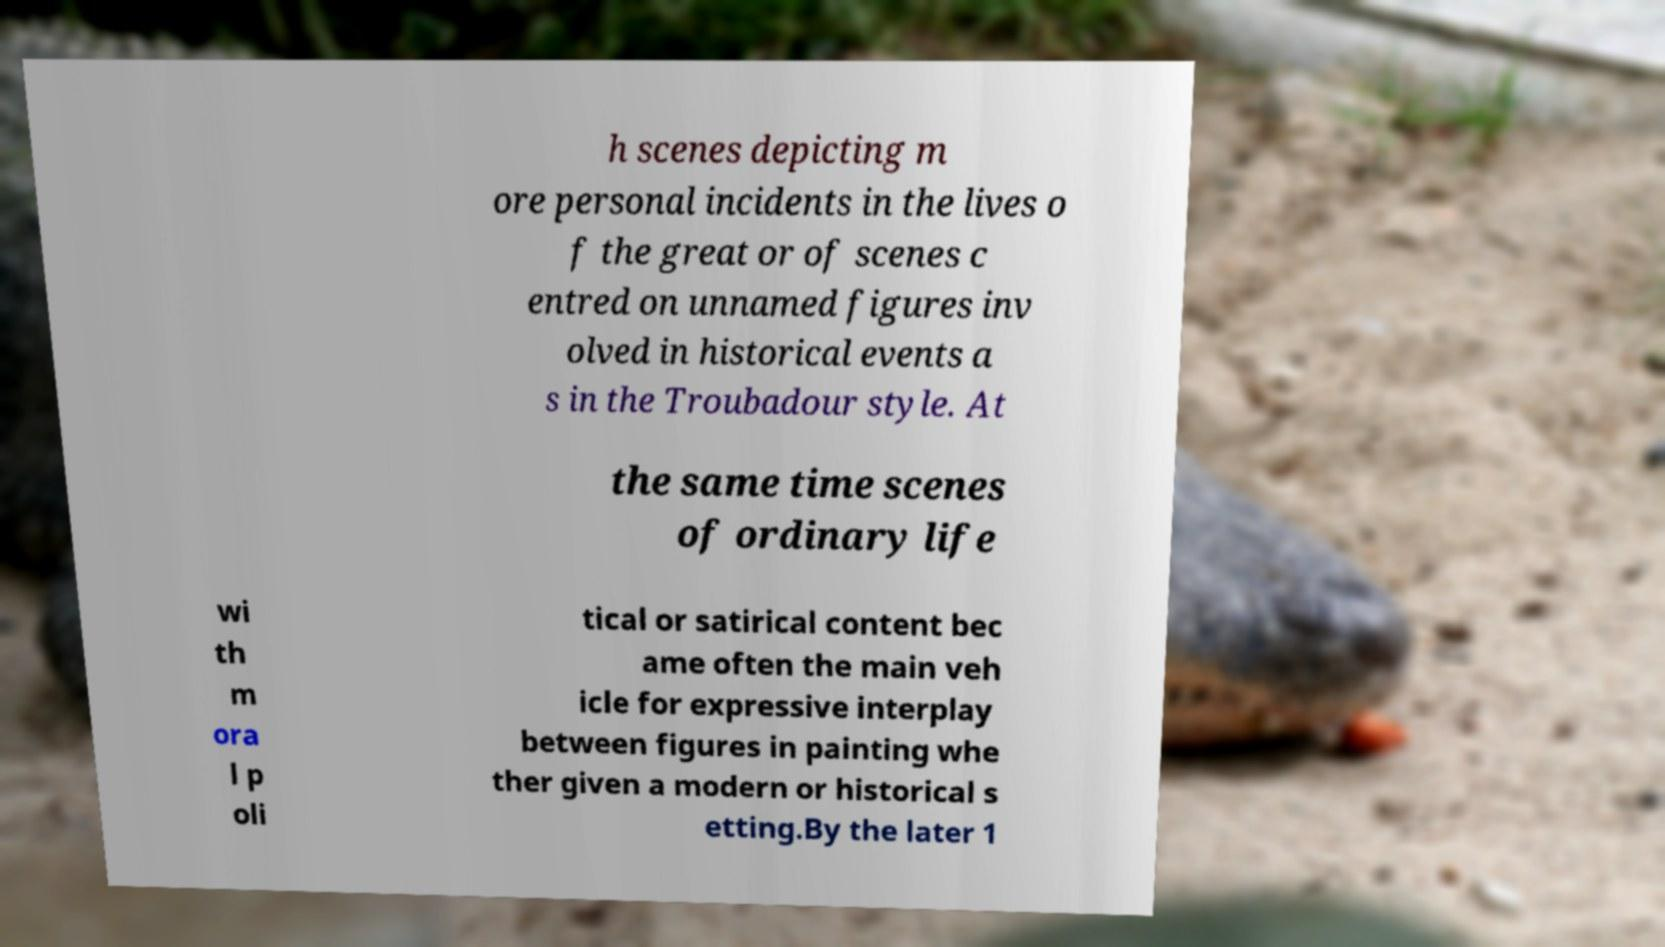What messages or text are displayed in this image? I need them in a readable, typed format. h scenes depicting m ore personal incidents in the lives o f the great or of scenes c entred on unnamed figures inv olved in historical events a s in the Troubadour style. At the same time scenes of ordinary life wi th m ora l p oli tical or satirical content bec ame often the main veh icle for expressive interplay between figures in painting whe ther given a modern or historical s etting.By the later 1 